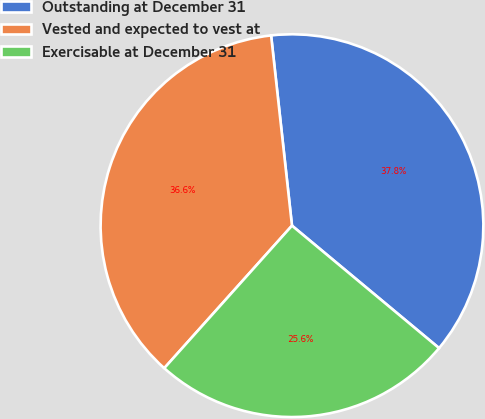Convert chart to OTSL. <chart><loc_0><loc_0><loc_500><loc_500><pie_chart><fcel>Outstanding at December 31<fcel>Vested and expected to vest at<fcel>Exercisable at December 31<nl><fcel>37.79%<fcel>36.63%<fcel>25.58%<nl></chart> 